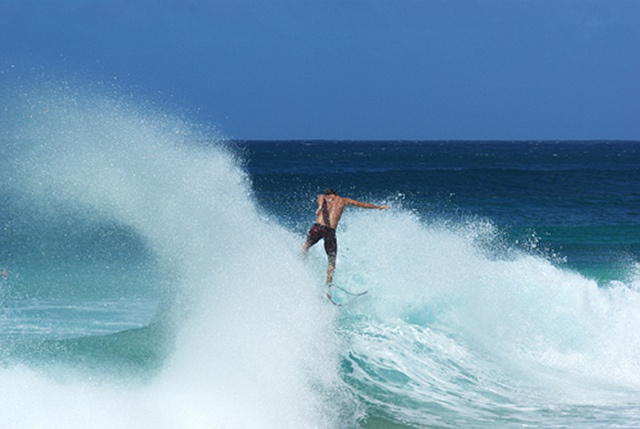Describe the objects in this image and their specific colors. I can see people in gray, black, and darkgray tones and surfboard in gray, lightblue, and darkgray tones in this image. 